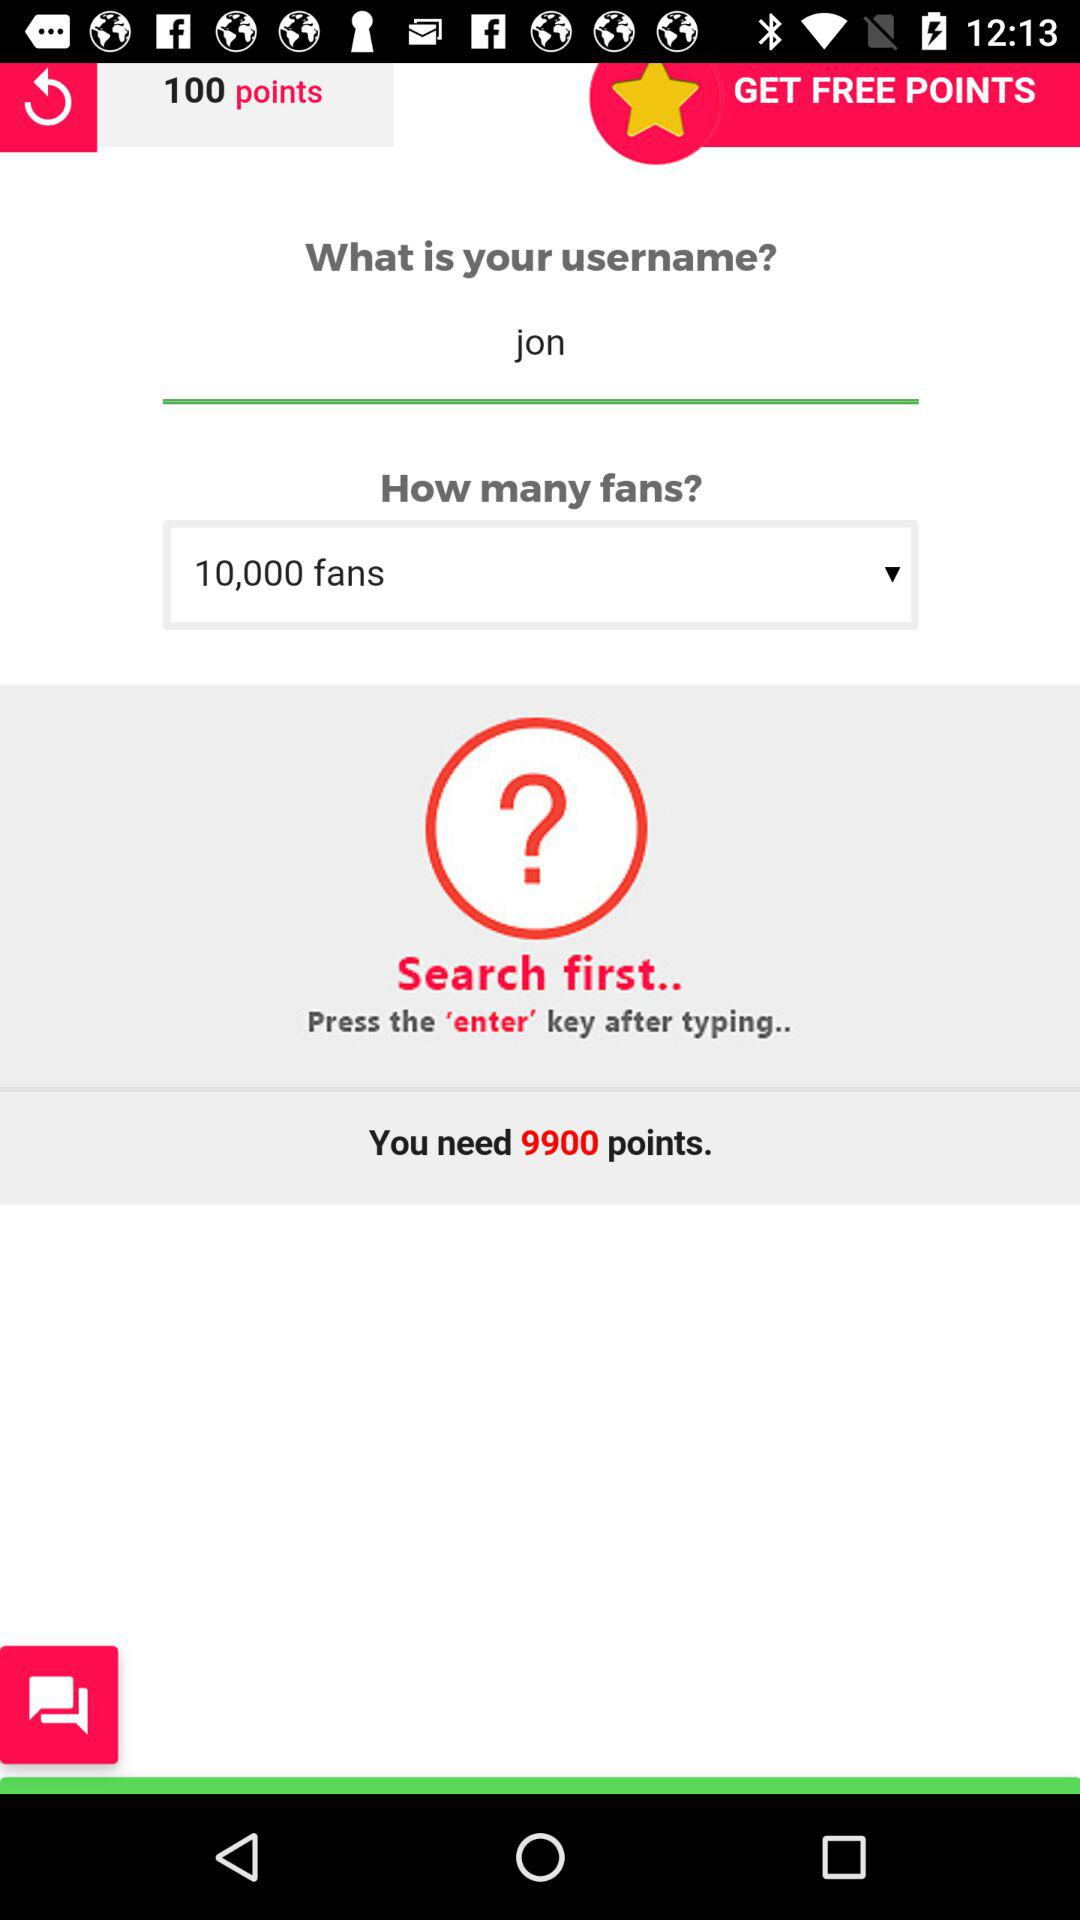How many more points do I need to get to 10,000 fans?
Answer the question using a single word or phrase. 9900 